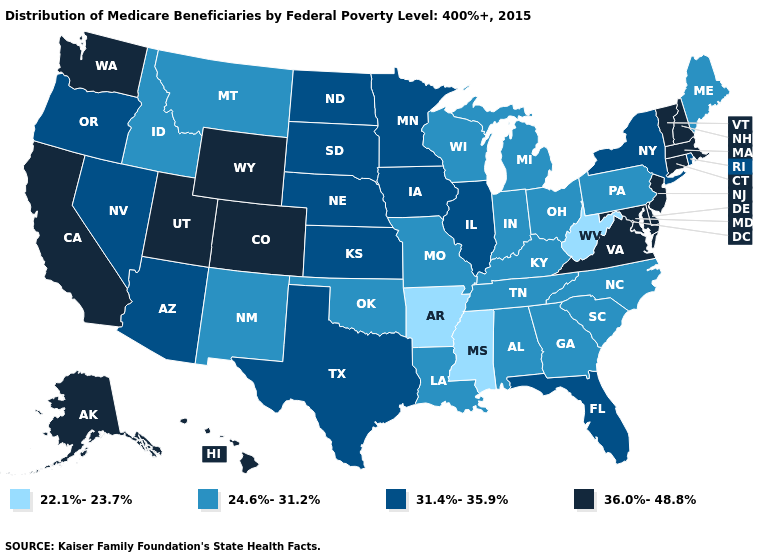What is the value of Wyoming?
Write a very short answer. 36.0%-48.8%. Name the states that have a value in the range 36.0%-48.8%?
Quick response, please. Alaska, California, Colorado, Connecticut, Delaware, Hawaii, Maryland, Massachusetts, New Hampshire, New Jersey, Utah, Vermont, Virginia, Washington, Wyoming. What is the lowest value in states that border North Carolina?
Write a very short answer. 24.6%-31.2%. What is the highest value in the West ?
Be succinct. 36.0%-48.8%. Name the states that have a value in the range 24.6%-31.2%?
Concise answer only. Alabama, Georgia, Idaho, Indiana, Kentucky, Louisiana, Maine, Michigan, Missouri, Montana, New Mexico, North Carolina, Ohio, Oklahoma, Pennsylvania, South Carolina, Tennessee, Wisconsin. Does Idaho have the same value as Maine?
Give a very brief answer. Yes. Among the states that border Oklahoma , does Colorado have the highest value?
Write a very short answer. Yes. Does the first symbol in the legend represent the smallest category?
Be succinct. Yes. Name the states that have a value in the range 24.6%-31.2%?
Quick response, please. Alabama, Georgia, Idaho, Indiana, Kentucky, Louisiana, Maine, Michigan, Missouri, Montana, New Mexico, North Carolina, Ohio, Oklahoma, Pennsylvania, South Carolina, Tennessee, Wisconsin. What is the value of Alabama?
Give a very brief answer. 24.6%-31.2%. Does New Jersey have the highest value in the Northeast?
Be succinct. Yes. Does Kansas have the highest value in the USA?
Answer briefly. No. Name the states that have a value in the range 36.0%-48.8%?
Short answer required. Alaska, California, Colorado, Connecticut, Delaware, Hawaii, Maryland, Massachusetts, New Hampshire, New Jersey, Utah, Vermont, Virginia, Washington, Wyoming. Which states hav the highest value in the Northeast?
Write a very short answer. Connecticut, Massachusetts, New Hampshire, New Jersey, Vermont. What is the value of Utah?
Write a very short answer. 36.0%-48.8%. 